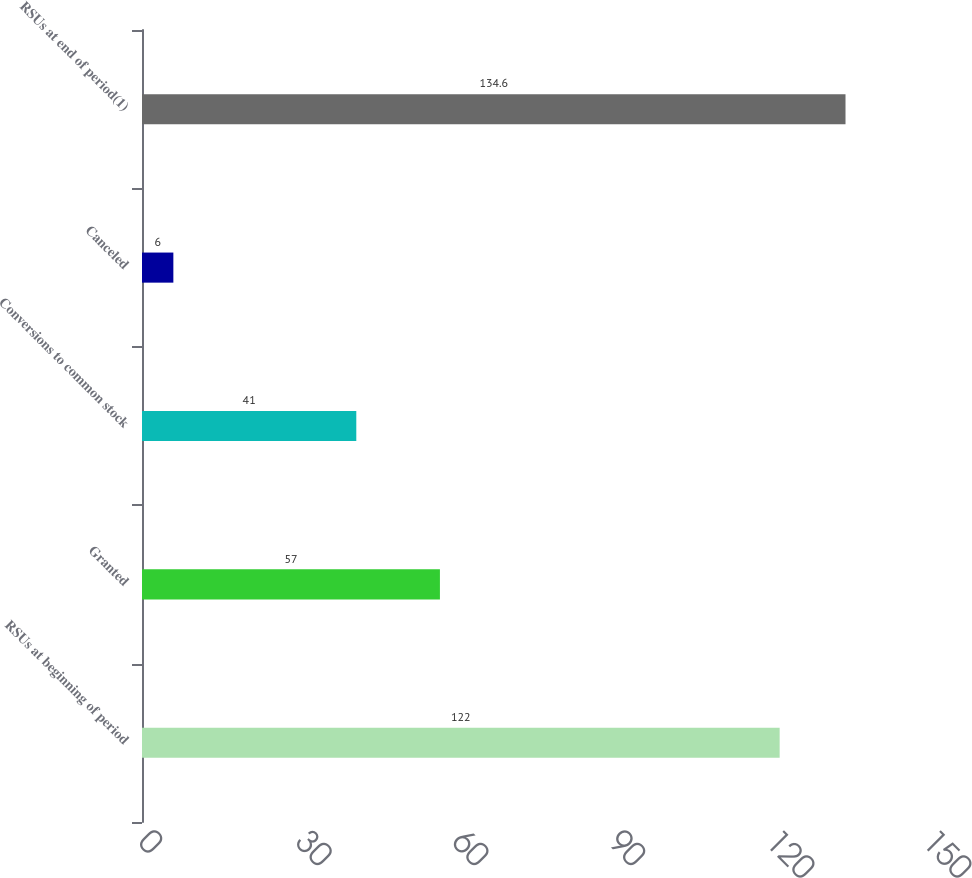Convert chart to OTSL. <chart><loc_0><loc_0><loc_500><loc_500><bar_chart><fcel>RSUs at beginning of period<fcel>Granted<fcel>Conversions to common stock<fcel>Canceled<fcel>RSUs at end of period(1)<nl><fcel>122<fcel>57<fcel>41<fcel>6<fcel>134.6<nl></chart> 